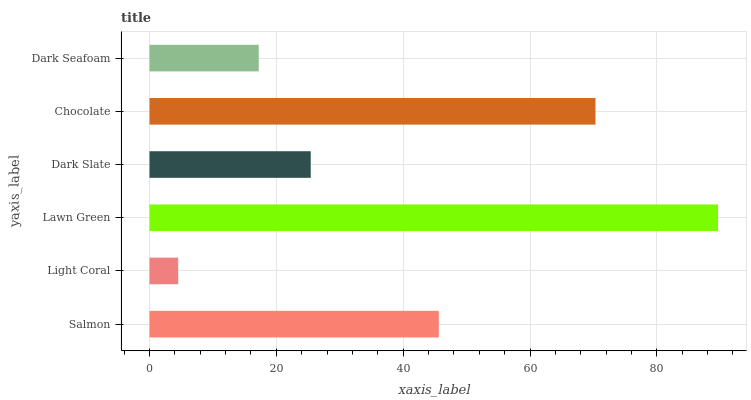Is Light Coral the minimum?
Answer yes or no. Yes. Is Lawn Green the maximum?
Answer yes or no. Yes. Is Lawn Green the minimum?
Answer yes or no. No. Is Light Coral the maximum?
Answer yes or no. No. Is Lawn Green greater than Light Coral?
Answer yes or no. Yes. Is Light Coral less than Lawn Green?
Answer yes or no. Yes. Is Light Coral greater than Lawn Green?
Answer yes or no. No. Is Lawn Green less than Light Coral?
Answer yes or no. No. Is Salmon the high median?
Answer yes or no. Yes. Is Dark Slate the low median?
Answer yes or no. Yes. Is Chocolate the high median?
Answer yes or no. No. Is Salmon the low median?
Answer yes or no. No. 